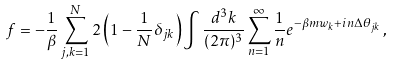<formula> <loc_0><loc_0><loc_500><loc_500>f = - \frac { 1 } { \beta } \sum ^ { N } _ { j , k = 1 } 2 \left ( 1 - \frac { 1 } { N } \delta _ { j k } \right ) \int \frac { d ^ { 3 } k } { ( 2 \pi ) ^ { 3 } } \sum _ { n = 1 } ^ { \infty } \frac { 1 } { n } e ^ { - \beta m w _ { k } + i n \Delta \theta _ { j k } } \, ,</formula> 